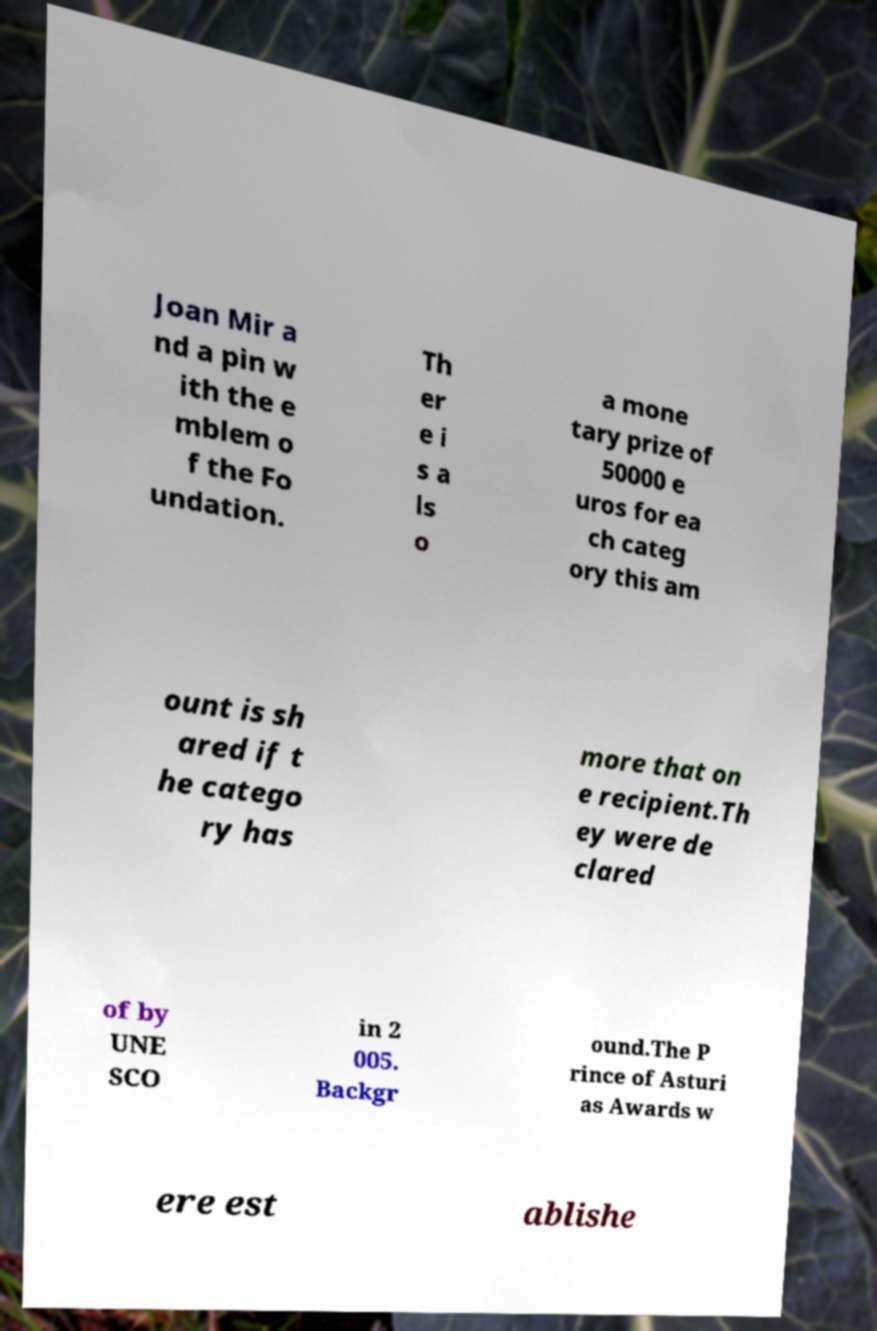Can you read and provide the text displayed in the image?This photo seems to have some interesting text. Can you extract and type it out for me? Joan Mir a nd a pin w ith the e mblem o f the Fo undation. Th er e i s a ls o a mone tary prize of 50000 e uros for ea ch categ ory this am ount is sh ared if t he catego ry has more that on e recipient.Th ey were de clared of by UNE SCO in 2 005. Backgr ound.The P rince of Asturi as Awards w ere est ablishe 